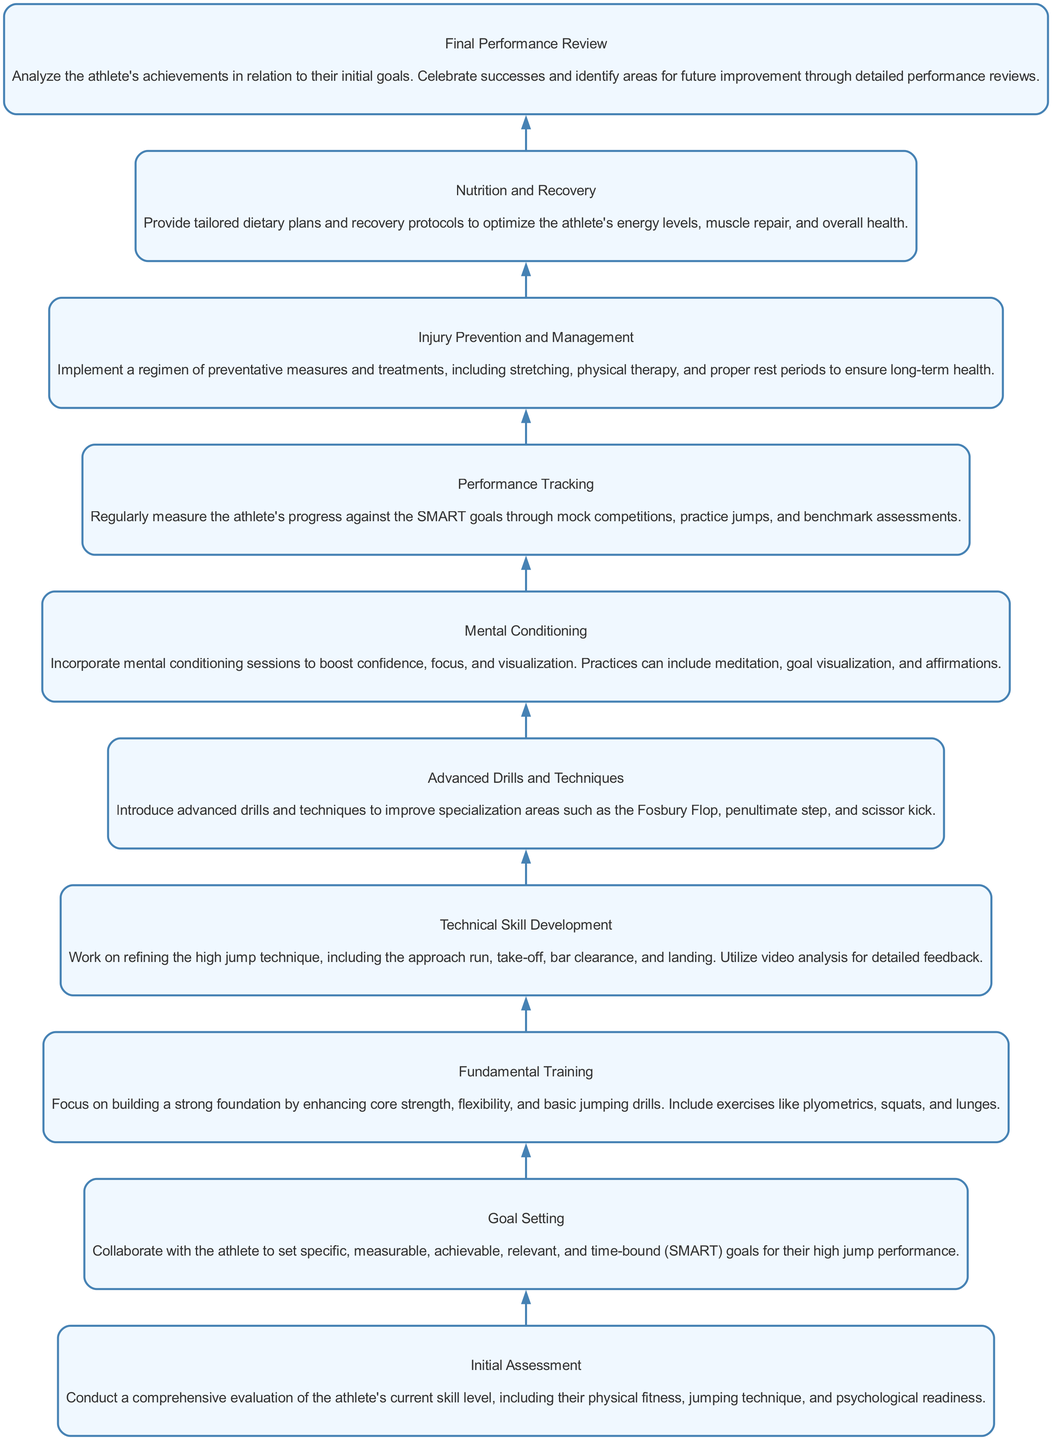What is the first step in the training plan? The diagram shows the first step labeled "Initial Assessment." This is where a comprehensive evaluation starts.
Answer: Initial Assessment How many total steps are in the training plan? By counting each node in the diagram, there are ten distinct steps listed from bottom to top.
Answer: 10 What is the last step in the training plan? According to the flow chart, the final node is labeled "Final Performance Review," which indicates the conclusion of the training process.
Answer: Final Performance Review Which step directly precedes "Mental Conditioning"? The diagram illustrates that "Technical Skill Development" is directly connected to and feeds into the "Mental Conditioning" step.
Answer: Technical Skill Development What type of goals should be set during the "Goal Setting" phase? The description under "Goal Setting" specifies that the goals must be SMART - specific, measurable, achievable, relevant, and time-bound.
Answer: SMART During which phase is injury prevention addressed in the training plan? The diagram identifies "Injury Prevention and Management" as a specific step, showing that it occurs distinctly in the training plan.
Answer: Injury Prevention and Management Which step involves video analysis for detailed feedback? The "Technical Skill Development" step emphasizes the use of video analysis as part of refining jumping technique.
Answer: Technical Skill Development What are examples of exercises included in "Fundamental Training"? The node for "Fundamental Training" mentions plyometrics, squats, and lunges as key exercises to build strength and flexibility.
Answer: Plyometrics, squats, and lunges What is the primary focus of the "Advanced Drills and Techniques" step? This step specifically focuses on improving specialization areas like the Fosbury Flop, the penultimate step, and the scissor kick.
Answer: Fosbury Flop, penultimate step, scissor kick How does "Performance Tracking" contribute to the athlete's progress? "Performance Tracking" regularly measures the athlete's progress against their SMART goals through various assessments and practices, ensuring growth is monitored.
Answer: Regular measurement against SMART goals 